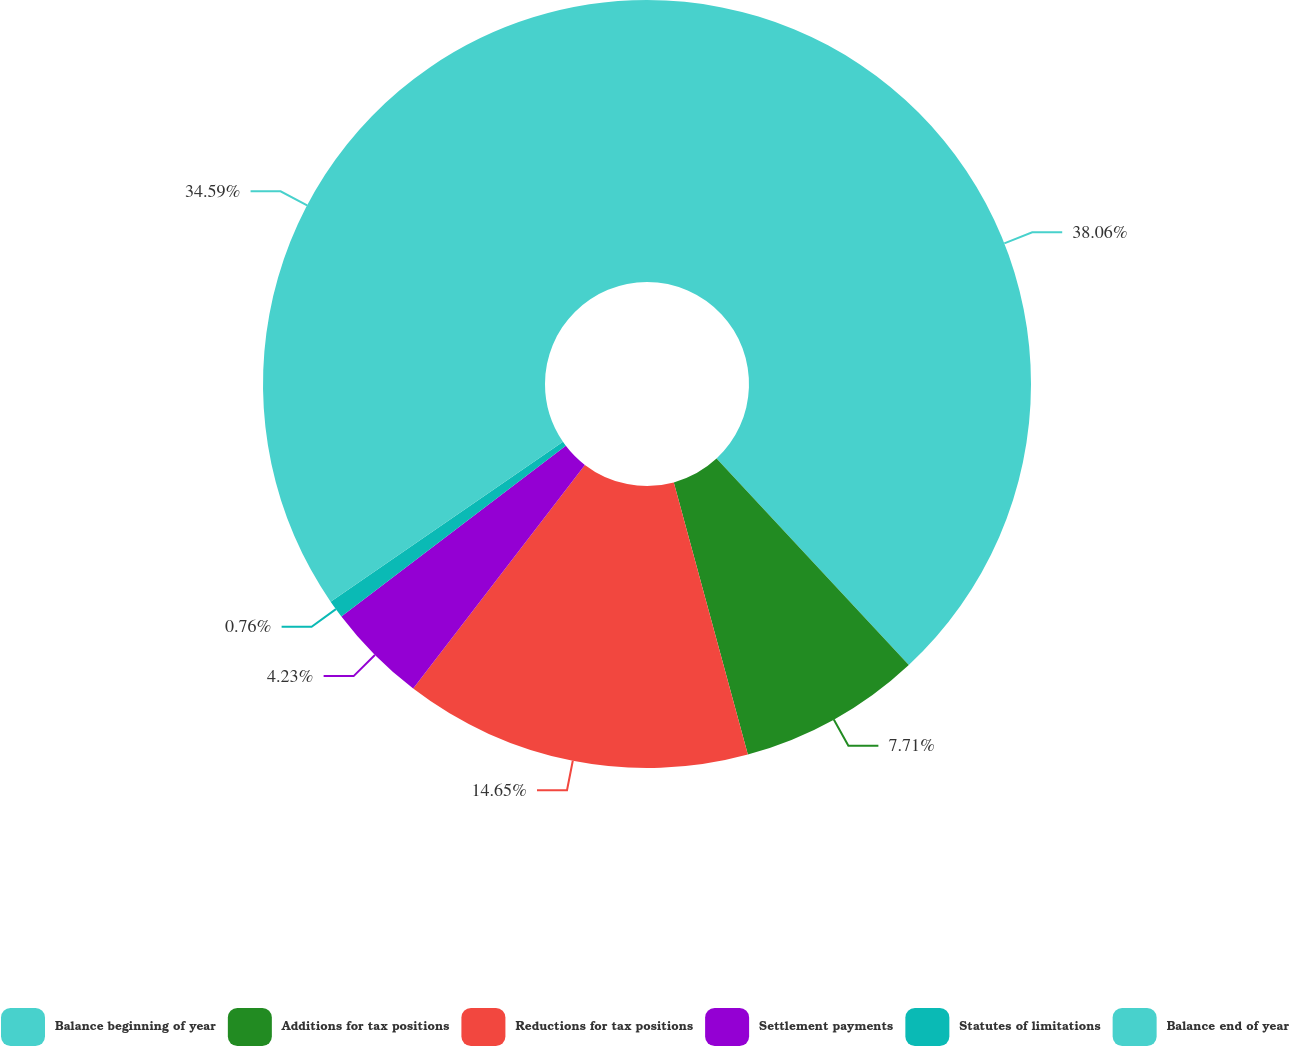Convert chart. <chart><loc_0><loc_0><loc_500><loc_500><pie_chart><fcel>Balance beginning of year<fcel>Additions for tax positions<fcel>Reductions for tax positions<fcel>Settlement payments<fcel>Statutes of limitations<fcel>Balance end of year<nl><fcel>38.06%<fcel>7.71%<fcel>14.65%<fcel>4.23%<fcel>0.76%<fcel>34.59%<nl></chart> 